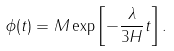Convert formula to latex. <formula><loc_0><loc_0><loc_500><loc_500>\phi ( t ) = M \exp \left [ - \frac { \lambda } { 3 H } t \right ] .</formula> 